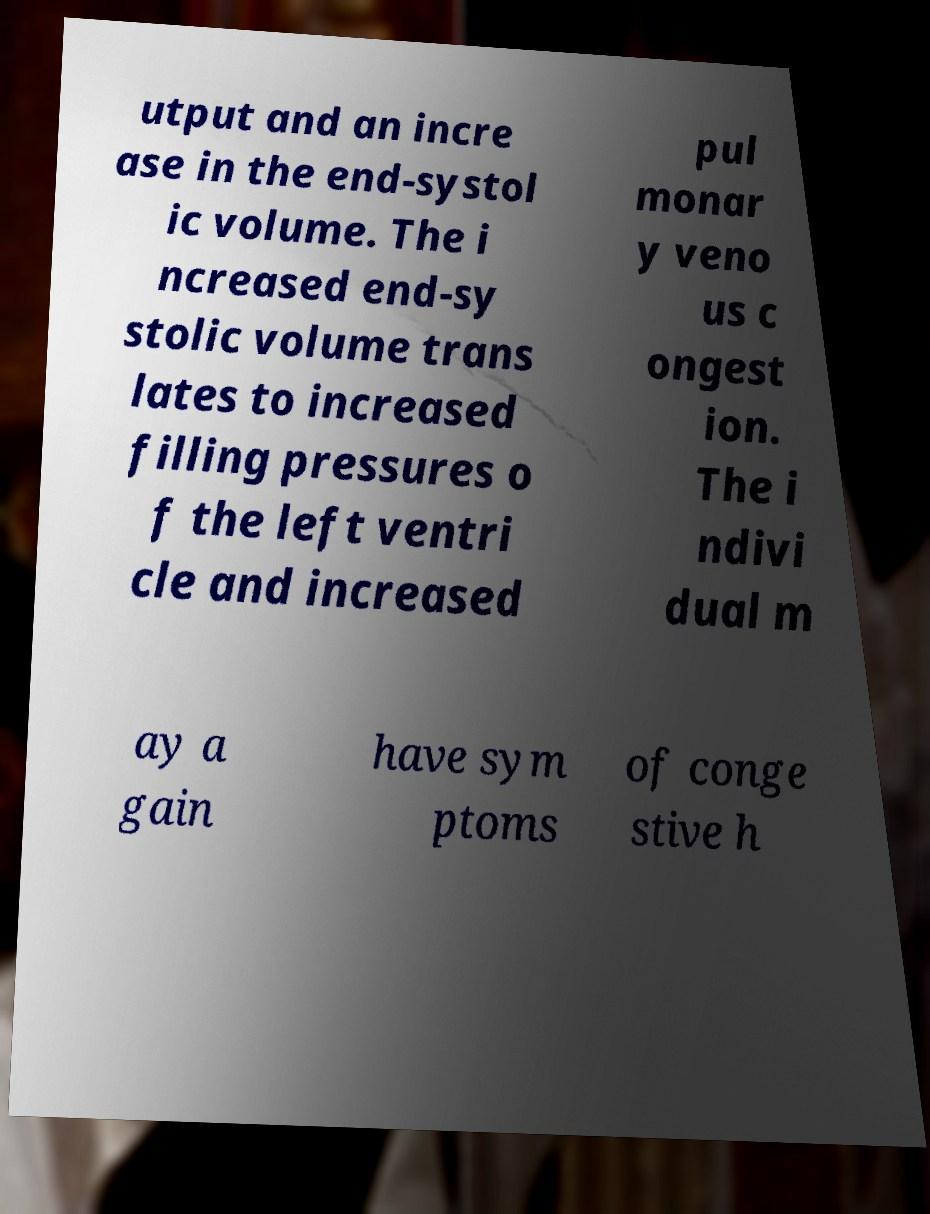Can you read and provide the text displayed in the image?This photo seems to have some interesting text. Can you extract and type it out for me? utput and an incre ase in the end-systol ic volume. The i ncreased end-sy stolic volume trans lates to increased filling pressures o f the left ventri cle and increased pul monar y veno us c ongest ion. The i ndivi dual m ay a gain have sym ptoms of conge stive h 